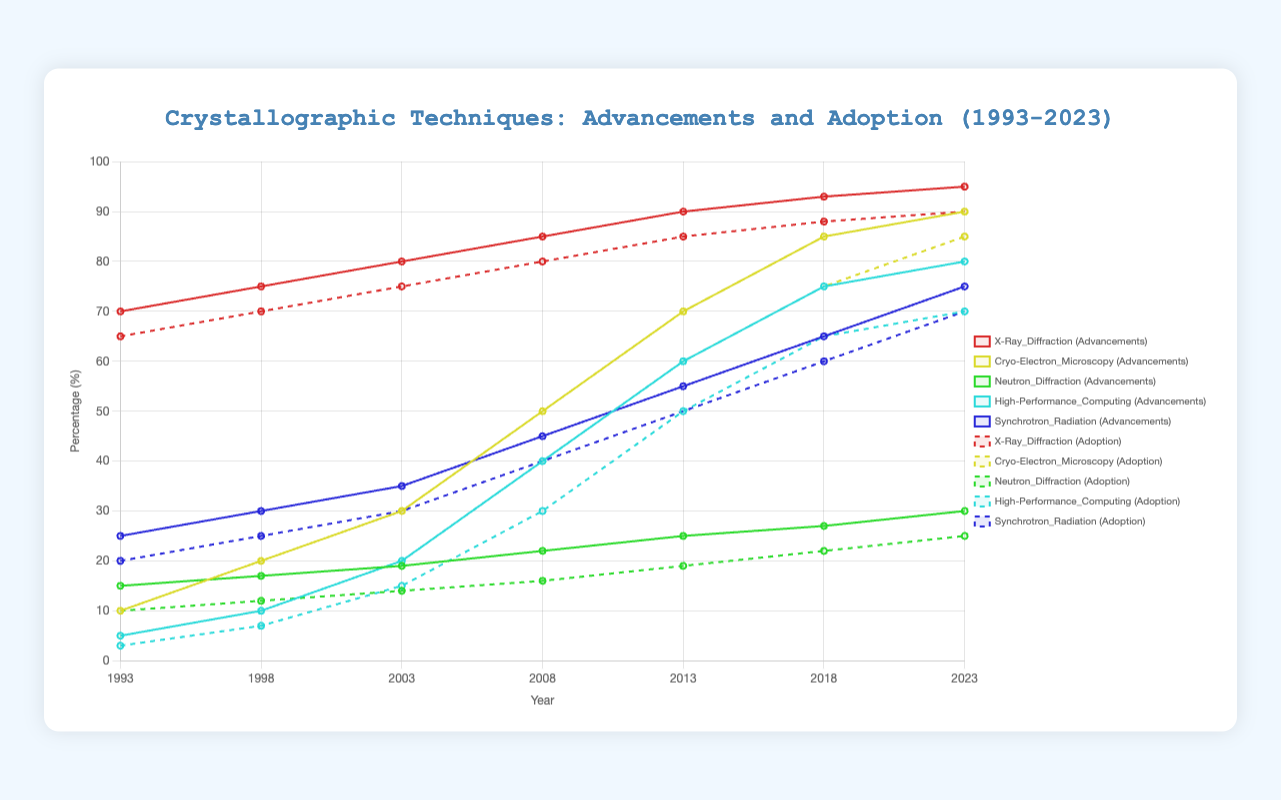What technological advancement showed the most consistent growth over the years? The data shows that X-Ray Diffraction had the most steady growth, increasing its advancements from 70% in 1993 to 95% in 2023. This growth is relatively smooth compared to the other techniques, which exhibit more rapid or irregular increases at certain points.
Answer: X-Ray Diffraction Which technique had the highest adoption rate in 2023? In 2023, Cryo-Electron Microscopy had the highest adoption rate at 85%, surpassing all other techniques. This is evident when comparing the adoption rates of all listed techniques for the year 2023.
Answer: Cryo-Electron Microscopy Compare the advancements and adoption rates of Neutron Diffraction in 2013. Which one was higher and by how much? In 2013, the advancement of Neutron Diffraction was at 25%, while its adoption rate was 19%. To find the difference, subtract the adoption rate from the advancement rate: 25% - 19% = 6%.
Answer: Advancements were higher by 6% How did the adoption rate of High-Performance Computing change between 1998 and 2003? The adoption rate of High-Performance Computing in 1998 was 7%, and it increased to 15% in 2003. So, the change is: 15% - 7% = 8%.
Answer: Increased by 8% Which technique has the smallest gap between advancements and adoption rates in 2023? In 2023, X-Ray Diffraction shows a 95% technological advancement and a 90% adoption rate. The gap can be calculated as follows: 95% - 90% = 5%. Comparing this gap with other techniques' gaps in 2023, it's the smallest.
Answer: X-Ray Diffraction What is the second highest technological advancement in 2008? In 2008, the technological advancements for each technique were:
- X-Ray Diffraction: 85%
- Cryo-Electron Microscopy: 50%
- Neutron Diffraction: 22%
- High-Performance Computing: 40%
- Synchrotron Radiation: 45%
The second highest value here is for Synchrotron Radiation at 45%.
Answer: Synchrotron Radiation Calculate the average advancement for Cryo-Electron Microscopy from 1993 to 2023. The advancements for Cryo-Electron Microscopy are: 10%, 20%, 30%, 50%, 70%, 85%, 90%. To find the average: (10 + 20 + 30 + 50 + 70 + 85 + 90) / 7 = 50.7%.
Answer: 50.7% Identify the year when Synchrotron Radiation adoption rate first surpassed 40%. Reviewing the adoption rates for Synchrotron Radiation: 1993: 20%, 1998: 25%, 2003: 30%, 2008: 40%, 2013: 50%. The year it first surpasses 40% is in 2013.
Answer: 2013 Which techniques had a higher adoption rate than X-Ray Diffraction in 2018? In 2018, the adoption rates are:
- X-Ray Diffraction: 88%
- Cryo-Electron Microscopy: 75%
- Neutron Diffraction: 22%
- High-Performance Computing: 65%
- Synchrotron Radiation: 60%
No technique had a higher adoption rate than X-Ray Diffraction in 2018 based on these figures.
Answer: None 